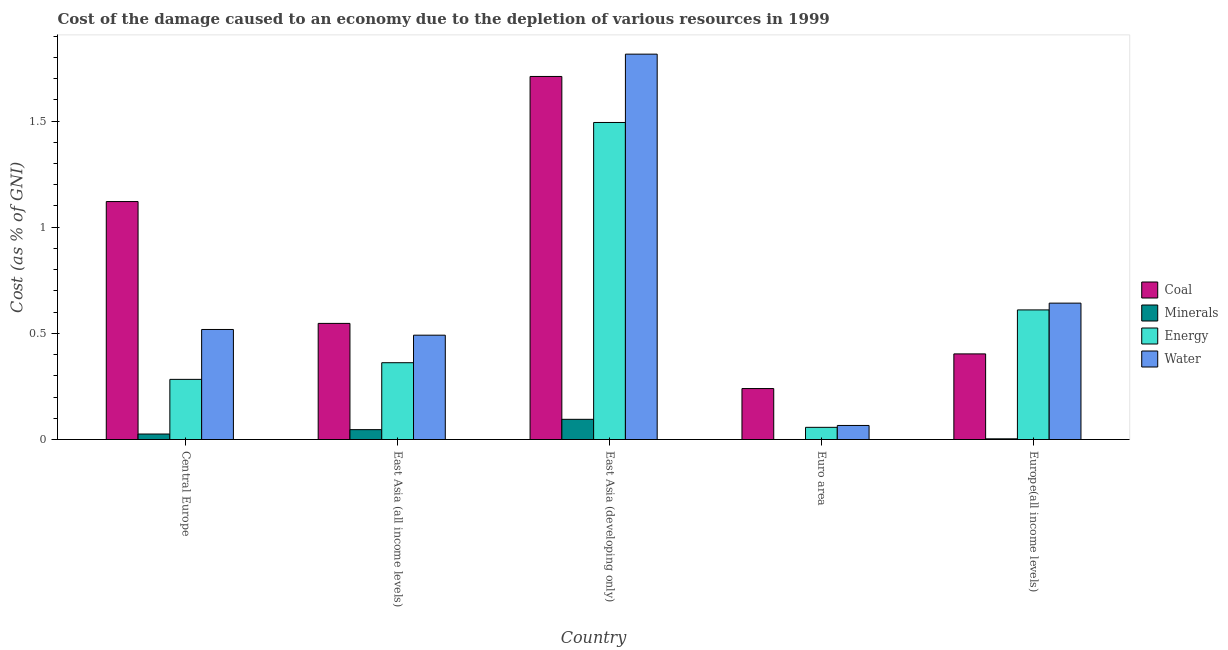What is the label of the 5th group of bars from the left?
Keep it short and to the point. Europe(all income levels). In how many cases, is the number of bars for a given country not equal to the number of legend labels?
Keep it short and to the point. 0. What is the cost of damage due to depletion of water in East Asia (all income levels)?
Offer a terse response. 0.49. Across all countries, what is the maximum cost of damage due to depletion of minerals?
Offer a terse response. 0.1. Across all countries, what is the minimum cost of damage due to depletion of coal?
Provide a short and direct response. 0.24. In which country was the cost of damage due to depletion of coal maximum?
Offer a very short reply. East Asia (developing only). What is the total cost of damage due to depletion of energy in the graph?
Your answer should be compact. 2.81. What is the difference between the cost of damage due to depletion of minerals in East Asia (developing only) and that in Euro area?
Your answer should be very brief. 0.1. What is the difference between the cost of damage due to depletion of energy in East Asia (all income levels) and the cost of damage due to depletion of water in Central Europe?
Provide a succinct answer. -0.16. What is the average cost of damage due to depletion of energy per country?
Give a very brief answer. 0.56. What is the difference between the cost of damage due to depletion of water and cost of damage due to depletion of coal in Euro area?
Keep it short and to the point. -0.17. In how many countries, is the cost of damage due to depletion of water greater than 1.7 %?
Provide a succinct answer. 1. What is the ratio of the cost of damage due to depletion of water in East Asia (developing only) to that in Euro area?
Make the answer very short. 27.42. Is the difference between the cost of damage due to depletion of water in Central Europe and East Asia (all income levels) greater than the difference between the cost of damage due to depletion of minerals in Central Europe and East Asia (all income levels)?
Your answer should be compact. Yes. What is the difference between the highest and the second highest cost of damage due to depletion of minerals?
Keep it short and to the point. 0.05. What is the difference between the highest and the lowest cost of damage due to depletion of water?
Provide a succinct answer. 1.75. What does the 3rd bar from the left in Central Europe represents?
Ensure brevity in your answer.  Energy. What does the 4th bar from the right in East Asia (developing only) represents?
Your response must be concise. Coal. Is it the case that in every country, the sum of the cost of damage due to depletion of coal and cost of damage due to depletion of minerals is greater than the cost of damage due to depletion of energy?
Provide a succinct answer. No. Are all the bars in the graph horizontal?
Make the answer very short. No. How many countries are there in the graph?
Provide a short and direct response. 5. Where does the legend appear in the graph?
Your answer should be compact. Center right. How are the legend labels stacked?
Your response must be concise. Vertical. What is the title of the graph?
Make the answer very short. Cost of the damage caused to an economy due to the depletion of various resources in 1999 . Does "Source data assessment" appear as one of the legend labels in the graph?
Keep it short and to the point. No. What is the label or title of the Y-axis?
Offer a terse response. Cost (as % of GNI). What is the Cost (as % of GNI) in Coal in Central Europe?
Make the answer very short. 1.12. What is the Cost (as % of GNI) of Minerals in Central Europe?
Make the answer very short. 0.03. What is the Cost (as % of GNI) in Energy in Central Europe?
Your response must be concise. 0.28. What is the Cost (as % of GNI) of Water in Central Europe?
Keep it short and to the point. 0.52. What is the Cost (as % of GNI) in Coal in East Asia (all income levels)?
Give a very brief answer. 0.55. What is the Cost (as % of GNI) of Minerals in East Asia (all income levels)?
Your answer should be very brief. 0.05. What is the Cost (as % of GNI) of Energy in East Asia (all income levels)?
Offer a very short reply. 0.36. What is the Cost (as % of GNI) in Water in East Asia (all income levels)?
Your response must be concise. 0.49. What is the Cost (as % of GNI) of Coal in East Asia (developing only)?
Provide a short and direct response. 1.71. What is the Cost (as % of GNI) of Minerals in East Asia (developing only)?
Your response must be concise. 0.1. What is the Cost (as % of GNI) of Energy in East Asia (developing only)?
Provide a short and direct response. 1.49. What is the Cost (as % of GNI) in Water in East Asia (developing only)?
Offer a terse response. 1.82. What is the Cost (as % of GNI) in Coal in Euro area?
Give a very brief answer. 0.24. What is the Cost (as % of GNI) in Minerals in Euro area?
Offer a very short reply. 0. What is the Cost (as % of GNI) in Energy in Euro area?
Your response must be concise. 0.06. What is the Cost (as % of GNI) of Water in Euro area?
Your answer should be very brief. 0.07. What is the Cost (as % of GNI) of Coal in Europe(all income levels)?
Offer a very short reply. 0.4. What is the Cost (as % of GNI) in Minerals in Europe(all income levels)?
Offer a very short reply. 0. What is the Cost (as % of GNI) of Energy in Europe(all income levels)?
Ensure brevity in your answer.  0.61. What is the Cost (as % of GNI) of Water in Europe(all income levels)?
Your answer should be very brief. 0.64. Across all countries, what is the maximum Cost (as % of GNI) of Coal?
Keep it short and to the point. 1.71. Across all countries, what is the maximum Cost (as % of GNI) in Minerals?
Your response must be concise. 0.1. Across all countries, what is the maximum Cost (as % of GNI) of Energy?
Your response must be concise. 1.49. Across all countries, what is the maximum Cost (as % of GNI) in Water?
Offer a terse response. 1.82. Across all countries, what is the minimum Cost (as % of GNI) of Coal?
Provide a succinct answer. 0.24. Across all countries, what is the minimum Cost (as % of GNI) of Minerals?
Provide a short and direct response. 0. Across all countries, what is the minimum Cost (as % of GNI) in Energy?
Ensure brevity in your answer.  0.06. Across all countries, what is the minimum Cost (as % of GNI) of Water?
Provide a succinct answer. 0.07. What is the total Cost (as % of GNI) of Coal in the graph?
Provide a succinct answer. 4.02. What is the total Cost (as % of GNI) of Minerals in the graph?
Your answer should be very brief. 0.17. What is the total Cost (as % of GNI) in Energy in the graph?
Make the answer very short. 2.81. What is the total Cost (as % of GNI) in Water in the graph?
Your response must be concise. 3.53. What is the difference between the Cost (as % of GNI) in Coal in Central Europe and that in East Asia (all income levels)?
Ensure brevity in your answer.  0.57. What is the difference between the Cost (as % of GNI) in Minerals in Central Europe and that in East Asia (all income levels)?
Offer a very short reply. -0.02. What is the difference between the Cost (as % of GNI) of Energy in Central Europe and that in East Asia (all income levels)?
Your answer should be very brief. -0.08. What is the difference between the Cost (as % of GNI) of Water in Central Europe and that in East Asia (all income levels)?
Offer a very short reply. 0.03. What is the difference between the Cost (as % of GNI) in Coal in Central Europe and that in East Asia (developing only)?
Make the answer very short. -0.59. What is the difference between the Cost (as % of GNI) in Minerals in Central Europe and that in East Asia (developing only)?
Your response must be concise. -0.07. What is the difference between the Cost (as % of GNI) in Energy in Central Europe and that in East Asia (developing only)?
Your answer should be very brief. -1.21. What is the difference between the Cost (as % of GNI) of Water in Central Europe and that in East Asia (developing only)?
Your response must be concise. -1.3. What is the difference between the Cost (as % of GNI) in Coal in Central Europe and that in Euro area?
Offer a very short reply. 0.88. What is the difference between the Cost (as % of GNI) in Minerals in Central Europe and that in Euro area?
Provide a succinct answer. 0.03. What is the difference between the Cost (as % of GNI) in Energy in Central Europe and that in Euro area?
Give a very brief answer. 0.23. What is the difference between the Cost (as % of GNI) in Water in Central Europe and that in Euro area?
Your answer should be very brief. 0.45. What is the difference between the Cost (as % of GNI) of Coal in Central Europe and that in Europe(all income levels)?
Ensure brevity in your answer.  0.72. What is the difference between the Cost (as % of GNI) in Minerals in Central Europe and that in Europe(all income levels)?
Your answer should be very brief. 0.02. What is the difference between the Cost (as % of GNI) of Energy in Central Europe and that in Europe(all income levels)?
Provide a short and direct response. -0.33. What is the difference between the Cost (as % of GNI) in Water in Central Europe and that in Europe(all income levels)?
Offer a terse response. -0.12. What is the difference between the Cost (as % of GNI) in Coal in East Asia (all income levels) and that in East Asia (developing only)?
Offer a terse response. -1.16. What is the difference between the Cost (as % of GNI) in Minerals in East Asia (all income levels) and that in East Asia (developing only)?
Keep it short and to the point. -0.05. What is the difference between the Cost (as % of GNI) in Energy in East Asia (all income levels) and that in East Asia (developing only)?
Offer a very short reply. -1.13. What is the difference between the Cost (as % of GNI) of Water in East Asia (all income levels) and that in East Asia (developing only)?
Provide a succinct answer. -1.32. What is the difference between the Cost (as % of GNI) of Coal in East Asia (all income levels) and that in Euro area?
Keep it short and to the point. 0.31. What is the difference between the Cost (as % of GNI) in Minerals in East Asia (all income levels) and that in Euro area?
Provide a succinct answer. 0.05. What is the difference between the Cost (as % of GNI) in Energy in East Asia (all income levels) and that in Euro area?
Give a very brief answer. 0.3. What is the difference between the Cost (as % of GNI) of Water in East Asia (all income levels) and that in Euro area?
Provide a short and direct response. 0.43. What is the difference between the Cost (as % of GNI) in Coal in East Asia (all income levels) and that in Europe(all income levels)?
Your answer should be very brief. 0.14. What is the difference between the Cost (as % of GNI) in Minerals in East Asia (all income levels) and that in Europe(all income levels)?
Offer a very short reply. 0.04. What is the difference between the Cost (as % of GNI) of Energy in East Asia (all income levels) and that in Europe(all income levels)?
Your response must be concise. -0.25. What is the difference between the Cost (as % of GNI) in Water in East Asia (all income levels) and that in Europe(all income levels)?
Ensure brevity in your answer.  -0.15. What is the difference between the Cost (as % of GNI) of Coal in East Asia (developing only) and that in Euro area?
Offer a terse response. 1.47. What is the difference between the Cost (as % of GNI) in Minerals in East Asia (developing only) and that in Euro area?
Your answer should be compact. 0.1. What is the difference between the Cost (as % of GNI) in Energy in East Asia (developing only) and that in Euro area?
Offer a terse response. 1.44. What is the difference between the Cost (as % of GNI) of Water in East Asia (developing only) and that in Euro area?
Ensure brevity in your answer.  1.75. What is the difference between the Cost (as % of GNI) in Coal in East Asia (developing only) and that in Europe(all income levels)?
Your answer should be very brief. 1.31. What is the difference between the Cost (as % of GNI) in Minerals in East Asia (developing only) and that in Europe(all income levels)?
Make the answer very short. 0.09. What is the difference between the Cost (as % of GNI) of Energy in East Asia (developing only) and that in Europe(all income levels)?
Offer a very short reply. 0.88. What is the difference between the Cost (as % of GNI) of Water in East Asia (developing only) and that in Europe(all income levels)?
Ensure brevity in your answer.  1.17. What is the difference between the Cost (as % of GNI) of Coal in Euro area and that in Europe(all income levels)?
Make the answer very short. -0.16. What is the difference between the Cost (as % of GNI) in Minerals in Euro area and that in Europe(all income levels)?
Your response must be concise. -0. What is the difference between the Cost (as % of GNI) in Energy in Euro area and that in Europe(all income levels)?
Provide a succinct answer. -0.55. What is the difference between the Cost (as % of GNI) in Water in Euro area and that in Europe(all income levels)?
Give a very brief answer. -0.58. What is the difference between the Cost (as % of GNI) in Coal in Central Europe and the Cost (as % of GNI) in Minerals in East Asia (all income levels)?
Offer a very short reply. 1.07. What is the difference between the Cost (as % of GNI) of Coal in Central Europe and the Cost (as % of GNI) of Energy in East Asia (all income levels)?
Your answer should be compact. 0.76. What is the difference between the Cost (as % of GNI) in Coal in Central Europe and the Cost (as % of GNI) in Water in East Asia (all income levels)?
Keep it short and to the point. 0.63. What is the difference between the Cost (as % of GNI) in Minerals in Central Europe and the Cost (as % of GNI) in Energy in East Asia (all income levels)?
Provide a succinct answer. -0.34. What is the difference between the Cost (as % of GNI) in Minerals in Central Europe and the Cost (as % of GNI) in Water in East Asia (all income levels)?
Make the answer very short. -0.47. What is the difference between the Cost (as % of GNI) in Energy in Central Europe and the Cost (as % of GNI) in Water in East Asia (all income levels)?
Offer a terse response. -0.21. What is the difference between the Cost (as % of GNI) of Coal in Central Europe and the Cost (as % of GNI) of Minerals in East Asia (developing only)?
Make the answer very short. 1.03. What is the difference between the Cost (as % of GNI) of Coal in Central Europe and the Cost (as % of GNI) of Energy in East Asia (developing only)?
Offer a terse response. -0.37. What is the difference between the Cost (as % of GNI) in Coal in Central Europe and the Cost (as % of GNI) in Water in East Asia (developing only)?
Ensure brevity in your answer.  -0.69. What is the difference between the Cost (as % of GNI) in Minerals in Central Europe and the Cost (as % of GNI) in Energy in East Asia (developing only)?
Give a very brief answer. -1.47. What is the difference between the Cost (as % of GNI) in Minerals in Central Europe and the Cost (as % of GNI) in Water in East Asia (developing only)?
Provide a succinct answer. -1.79. What is the difference between the Cost (as % of GNI) of Energy in Central Europe and the Cost (as % of GNI) of Water in East Asia (developing only)?
Offer a very short reply. -1.53. What is the difference between the Cost (as % of GNI) in Coal in Central Europe and the Cost (as % of GNI) in Minerals in Euro area?
Provide a succinct answer. 1.12. What is the difference between the Cost (as % of GNI) of Coal in Central Europe and the Cost (as % of GNI) of Energy in Euro area?
Give a very brief answer. 1.06. What is the difference between the Cost (as % of GNI) of Coal in Central Europe and the Cost (as % of GNI) of Water in Euro area?
Keep it short and to the point. 1.05. What is the difference between the Cost (as % of GNI) in Minerals in Central Europe and the Cost (as % of GNI) in Energy in Euro area?
Make the answer very short. -0.03. What is the difference between the Cost (as % of GNI) of Minerals in Central Europe and the Cost (as % of GNI) of Water in Euro area?
Keep it short and to the point. -0.04. What is the difference between the Cost (as % of GNI) of Energy in Central Europe and the Cost (as % of GNI) of Water in Euro area?
Your response must be concise. 0.22. What is the difference between the Cost (as % of GNI) of Coal in Central Europe and the Cost (as % of GNI) of Minerals in Europe(all income levels)?
Your answer should be very brief. 1.12. What is the difference between the Cost (as % of GNI) in Coal in Central Europe and the Cost (as % of GNI) in Energy in Europe(all income levels)?
Your answer should be compact. 0.51. What is the difference between the Cost (as % of GNI) in Coal in Central Europe and the Cost (as % of GNI) in Water in Europe(all income levels)?
Offer a very short reply. 0.48. What is the difference between the Cost (as % of GNI) in Minerals in Central Europe and the Cost (as % of GNI) in Energy in Europe(all income levels)?
Your answer should be very brief. -0.58. What is the difference between the Cost (as % of GNI) of Minerals in Central Europe and the Cost (as % of GNI) of Water in Europe(all income levels)?
Make the answer very short. -0.62. What is the difference between the Cost (as % of GNI) of Energy in Central Europe and the Cost (as % of GNI) of Water in Europe(all income levels)?
Give a very brief answer. -0.36. What is the difference between the Cost (as % of GNI) of Coal in East Asia (all income levels) and the Cost (as % of GNI) of Minerals in East Asia (developing only)?
Your response must be concise. 0.45. What is the difference between the Cost (as % of GNI) in Coal in East Asia (all income levels) and the Cost (as % of GNI) in Energy in East Asia (developing only)?
Keep it short and to the point. -0.95. What is the difference between the Cost (as % of GNI) in Coal in East Asia (all income levels) and the Cost (as % of GNI) in Water in East Asia (developing only)?
Offer a terse response. -1.27. What is the difference between the Cost (as % of GNI) in Minerals in East Asia (all income levels) and the Cost (as % of GNI) in Energy in East Asia (developing only)?
Make the answer very short. -1.45. What is the difference between the Cost (as % of GNI) in Minerals in East Asia (all income levels) and the Cost (as % of GNI) in Water in East Asia (developing only)?
Your answer should be compact. -1.77. What is the difference between the Cost (as % of GNI) in Energy in East Asia (all income levels) and the Cost (as % of GNI) in Water in East Asia (developing only)?
Your response must be concise. -1.45. What is the difference between the Cost (as % of GNI) in Coal in East Asia (all income levels) and the Cost (as % of GNI) in Minerals in Euro area?
Offer a very short reply. 0.55. What is the difference between the Cost (as % of GNI) in Coal in East Asia (all income levels) and the Cost (as % of GNI) in Energy in Euro area?
Your response must be concise. 0.49. What is the difference between the Cost (as % of GNI) in Coal in East Asia (all income levels) and the Cost (as % of GNI) in Water in Euro area?
Your response must be concise. 0.48. What is the difference between the Cost (as % of GNI) of Minerals in East Asia (all income levels) and the Cost (as % of GNI) of Energy in Euro area?
Your answer should be compact. -0.01. What is the difference between the Cost (as % of GNI) of Minerals in East Asia (all income levels) and the Cost (as % of GNI) of Water in Euro area?
Provide a succinct answer. -0.02. What is the difference between the Cost (as % of GNI) in Energy in East Asia (all income levels) and the Cost (as % of GNI) in Water in Euro area?
Keep it short and to the point. 0.3. What is the difference between the Cost (as % of GNI) in Coal in East Asia (all income levels) and the Cost (as % of GNI) in Minerals in Europe(all income levels)?
Keep it short and to the point. 0.54. What is the difference between the Cost (as % of GNI) of Coal in East Asia (all income levels) and the Cost (as % of GNI) of Energy in Europe(all income levels)?
Ensure brevity in your answer.  -0.06. What is the difference between the Cost (as % of GNI) in Coal in East Asia (all income levels) and the Cost (as % of GNI) in Water in Europe(all income levels)?
Your answer should be very brief. -0.1. What is the difference between the Cost (as % of GNI) in Minerals in East Asia (all income levels) and the Cost (as % of GNI) in Energy in Europe(all income levels)?
Keep it short and to the point. -0.56. What is the difference between the Cost (as % of GNI) in Minerals in East Asia (all income levels) and the Cost (as % of GNI) in Water in Europe(all income levels)?
Make the answer very short. -0.6. What is the difference between the Cost (as % of GNI) in Energy in East Asia (all income levels) and the Cost (as % of GNI) in Water in Europe(all income levels)?
Your response must be concise. -0.28. What is the difference between the Cost (as % of GNI) in Coal in East Asia (developing only) and the Cost (as % of GNI) in Minerals in Euro area?
Your answer should be compact. 1.71. What is the difference between the Cost (as % of GNI) of Coal in East Asia (developing only) and the Cost (as % of GNI) of Energy in Euro area?
Provide a succinct answer. 1.65. What is the difference between the Cost (as % of GNI) of Coal in East Asia (developing only) and the Cost (as % of GNI) of Water in Euro area?
Keep it short and to the point. 1.64. What is the difference between the Cost (as % of GNI) in Minerals in East Asia (developing only) and the Cost (as % of GNI) in Energy in Euro area?
Make the answer very short. 0.04. What is the difference between the Cost (as % of GNI) in Minerals in East Asia (developing only) and the Cost (as % of GNI) in Water in Euro area?
Provide a succinct answer. 0.03. What is the difference between the Cost (as % of GNI) in Energy in East Asia (developing only) and the Cost (as % of GNI) in Water in Euro area?
Your answer should be very brief. 1.43. What is the difference between the Cost (as % of GNI) in Coal in East Asia (developing only) and the Cost (as % of GNI) in Minerals in Europe(all income levels)?
Give a very brief answer. 1.71. What is the difference between the Cost (as % of GNI) in Coal in East Asia (developing only) and the Cost (as % of GNI) in Energy in Europe(all income levels)?
Give a very brief answer. 1.1. What is the difference between the Cost (as % of GNI) in Coal in East Asia (developing only) and the Cost (as % of GNI) in Water in Europe(all income levels)?
Offer a terse response. 1.07. What is the difference between the Cost (as % of GNI) of Minerals in East Asia (developing only) and the Cost (as % of GNI) of Energy in Europe(all income levels)?
Provide a short and direct response. -0.52. What is the difference between the Cost (as % of GNI) in Minerals in East Asia (developing only) and the Cost (as % of GNI) in Water in Europe(all income levels)?
Your response must be concise. -0.55. What is the difference between the Cost (as % of GNI) in Energy in East Asia (developing only) and the Cost (as % of GNI) in Water in Europe(all income levels)?
Provide a succinct answer. 0.85. What is the difference between the Cost (as % of GNI) of Coal in Euro area and the Cost (as % of GNI) of Minerals in Europe(all income levels)?
Keep it short and to the point. 0.24. What is the difference between the Cost (as % of GNI) of Coal in Euro area and the Cost (as % of GNI) of Energy in Europe(all income levels)?
Offer a terse response. -0.37. What is the difference between the Cost (as % of GNI) of Coal in Euro area and the Cost (as % of GNI) of Water in Europe(all income levels)?
Your response must be concise. -0.4. What is the difference between the Cost (as % of GNI) in Minerals in Euro area and the Cost (as % of GNI) in Energy in Europe(all income levels)?
Provide a short and direct response. -0.61. What is the difference between the Cost (as % of GNI) in Minerals in Euro area and the Cost (as % of GNI) in Water in Europe(all income levels)?
Give a very brief answer. -0.64. What is the difference between the Cost (as % of GNI) in Energy in Euro area and the Cost (as % of GNI) in Water in Europe(all income levels)?
Keep it short and to the point. -0.58. What is the average Cost (as % of GNI) in Coal per country?
Ensure brevity in your answer.  0.8. What is the average Cost (as % of GNI) of Minerals per country?
Provide a short and direct response. 0.03. What is the average Cost (as % of GNI) of Energy per country?
Offer a very short reply. 0.56. What is the average Cost (as % of GNI) of Water per country?
Ensure brevity in your answer.  0.71. What is the difference between the Cost (as % of GNI) in Coal and Cost (as % of GNI) in Minerals in Central Europe?
Provide a short and direct response. 1.09. What is the difference between the Cost (as % of GNI) in Coal and Cost (as % of GNI) in Energy in Central Europe?
Your response must be concise. 0.84. What is the difference between the Cost (as % of GNI) in Coal and Cost (as % of GNI) in Water in Central Europe?
Give a very brief answer. 0.6. What is the difference between the Cost (as % of GNI) of Minerals and Cost (as % of GNI) of Energy in Central Europe?
Your answer should be very brief. -0.26. What is the difference between the Cost (as % of GNI) in Minerals and Cost (as % of GNI) in Water in Central Europe?
Offer a terse response. -0.49. What is the difference between the Cost (as % of GNI) in Energy and Cost (as % of GNI) in Water in Central Europe?
Your answer should be very brief. -0.23. What is the difference between the Cost (as % of GNI) in Coal and Cost (as % of GNI) in Minerals in East Asia (all income levels)?
Your answer should be compact. 0.5. What is the difference between the Cost (as % of GNI) in Coal and Cost (as % of GNI) in Energy in East Asia (all income levels)?
Your response must be concise. 0.19. What is the difference between the Cost (as % of GNI) in Coal and Cost (as % of GNI) in Water in East Asia (all income levels)?
Give a very brief answer. 0.06. What is the difference between the Cost (as % of GNI) in Minerals and Cost (as % of GNI) in Energy in East Asia (all income levels)?
Give a very brief answer. -0.32. What is the difference between the Cost (as % of GNI) of Minerals and Cost (as % of GNI) of Water in East Asia (all income levels)?
Offer a terse response. -0.44. What is the difference between the Cost (as % of GNI) in Energy and Cost (as % of GNI) in Water in East Asia (all income levels)?
Offer a very short reply. -0.13. What is the difference between the Cost (as % of GNI) of Coal and Cost (as % of GNI) of Minerals in East Asia (developing only)?
Your response must be concise. 1.61. What is the difference between the Cost (as % of GNI) in Coal and Cost (as % of GNI) in Energy in East Asia (developing only)?
Offer a very short reply. 0.22. What is the difference between the Cost (as % of GNI) in Coal and Cost (as % of GNI) in Water in East Asia (developing only)?
Offer a very short reply. -0.11. What is the difference between the Cost (as % of GNI) of Minerals and Cost (as % of GNI) of Energy in East Asia (developing only)?
Your answer should be very brief. -1.4. What is the difference between the Cost (as % of GNI) in Minerals and Cost (as % of GNI) in Water in East Asia (developing only)?
Provide a short and direct response. -1.72. What is the difference between the Cost (as % of GNI) in Energy and Cost (as % of GNI) in Water in East Asia (developing only)?
Offer a very short reply. -0.32. What is the difference between the Cost (as % of GNI) of Coal and Cost (as % of GNI) of Minerals in Euro area?
Provide a succinct answer. 0.24. What is the difference between the Cost (as % of GNI) of Coal and Cost (as % of GNI) of Energy in Euro area?
Offer a terse response. 0.18. What is the difference between the Cost (as % of GNI) of Coal and Cost (as % of GNI) of Water in Euro area?
Your response must be concise. 0.17. What is the difference between the Cost (as % of GNI) of Minerals and Cost (as % of GNI) of Energy in Euro area?
Make the answer very short. -0.06. What is the difference between the Cost (as % of GNI) in Minerals and Cost (as % of GNI) in Water in Euro area?
Provide a short and direct response. -0.07. What is the difference between the Cost (as % of GNI) of Energy and Cost (as % of GNI) of Water in Euro area?
Provide a succinct answer. -0.01. What is the difference between the Cost (as % of GNI) of Coal and Cost (as % of GNI) of Minerals in Europe(all income levels)?
Offer a terse response. 0.4. What is the difference between the Cost (as % of GNI) of Coal and Cost (as % of GNI) of Energy in Europe(all income levels)?
Your response must be concise. -0.21. What is the difference between the Cost (as % of GNI) of Coal and Cost (as % of GNI) of Water in Europe(all income levels)?
Offer a very short reply. -0.24. What is the difference between the Cost (as % of GNI) of Minerals and Cost (as % of GNI) of Energy in Europe(all income levels)?
Offer a very short reply. -0.61. What is the difference between the Cost (as % of GNI) of Minerals and Cost (as % of GNI) of Water in Europe(all income levels)?
Your answer should be compact. -0.64. What is the difference between the Cost (as % of GNI) in Energy and Cost (as % of GNI) in Water in Europe(all income levels)?
Offer a terse response. -0.03. What is the ratio of the Cost (as % of GNI) of Coal in Central Europe to that in East Asia (all income levels)?
Your response must be concise. 2.05. What is the ratio of the Cost (as % of GNI) of Minerals in Central Europe to that in East Asia (all income levels)?
Your response must be concise. 0.56. What is the ratio of the Cost (as % of GNI) of Energy in Central Europe to that in East Asia (all income levels)?
Provide a short and direct response. 0.78. What is the ratio of the Cost (as % of GNI) of Water in Central Europe to that in East Asia (all income levels)?
Give a very brief answer. 1.05. What is the ratio of the Cost (as % of GNI) of Coal in Central Europe to that in East Asia (developing only)?
Provide a succinct answer. 0.66. What is the ratio of the Cost (as % of GNI) of Minerals in Central Europe to that in East Asia (developing only)?
Keep it short and to the point. 0.27. What is the ratio of the Cost (as % of GNI) in Energy in Central Europe to that in East Asia (developing only)?
Give a very brief answer. 0.19. What is the ratio of the Cost (as % of GNI) in Water in Central Europe to that in East Asia (developing only)?
Keep it short and to the point. 0.29. What is the ratio of the Cost (as % of GNI) of Coal in Central Europe to that in Euro area?
Provide a short and direct response. 4.67. What is the ratio of the Cost (as % of GNI) of Minerals in Central Europe to that in Euro area?
Provide a short and direct response. 222.12. What is the ratio of the Cost (as % of GNI) of Energy in Central Europe to that in Euro area?
Your answer should be very brief. 4.94. What is the ratio of the Cost (as % of GNI) of Water in Central Europe to that in Euro area?
Provide a succinct answer. 7.83. What is the ratio of the Cost (as % of GNI) of Coal in Central Europe to that in Europe(all income levels)?
Provide a succinct answer. 2.78. What is the ratio of the Cost (as % of GNI) of Minerals in Central Europe to that in Europe(all income levels)?
Keep it short and to the point. 7.99. What is the ratio of the Cost (as % of GNI) in Energy in Central Europe to that in Europe(all income levels)?
Offer a very short reply. 0.46. What is the ratio of the Cost (as % of GNI) of Water in Central Europe to that in Europe(all income levels)?
Give a very brief answer. 0.81. What is the ratio of the Cost (as % of GNI) in Coal in East Asia (all income levels) to that in East Asia (developing only)?
Your response must be concise. 0.32. What is the ratio of the Cost (as % of GNI) of Minerals in East Asia (all income levels) to that in East Asia (developing only)?
Keep it short and to the point. 0.49. What is the ratio of the Cost (as % of GNI) of Energy in East Asia (all income levels) to that in East Asia (developing only)?
Your response must be concise. 0.24. What is the ratio of the Cost (as % of GNI) in Water in East Asia (all income levels) to that in East Asia (developing only)?
Offer a very short reply. 0.27. What is the ratio of the Cost (as % of GNI) of Coal in East Asia (all income levels) to that in Euro area?
Provide a succinct answer. 2.28. What is the ratio of the Cost (as % of GNI) in Minerals in East Asia (all income levels) to that in Euro area?
Make the answer very short. 398.85. What is the ratio of the Cost (as % of GNI) of Energy in East Asia (all income levels) to that in Euro area?
Your answer should be very brief. 6.3. What is the ratio of the Cost (as % of GNI) of Water in East Asia (all income levels) to that in Euro area?
Provide a short and direct response. 7.42. What is the ratio of the Cost (as % of GNI) in Coal in East Asia (all income levels) to that in Europe(all income levels)?
Offer a very short reply. 1.36. What is the ratio of the Cost (as % of GNI) of Minerals in East Asia (all income levels) to that in Europe(all income levels)?
Make the answer very short. 14.35. What is the ratio of the Cost (as % of GNI) in Energy in East Asia (all income levels) to that in Europe(all income levels)?
Give a very brief answer. 0.59. What is the ratio of the Cost (as % of GNI) in Water in East Asia (all income levels) to that in Europe(all income levels)?
Offer a very short reply. 0.77. What is the ratio of the Cost (as % of GNI) of Coal in East Asia (developing only) to that in Euro area?
Your answer should be compact. 7.12. What is the ratio of the Cost (as % of GNI) in Minerals in East Asia (developing only) to that in Euro area?
Provide a succinct answer. 815.69. What is the ratio of the Cost (as % of GNI) in Energy in East Asia (developing only) to that in Euro area?
Give a very brief answer. 26.02. What is the ratio of the Cost (as % of GNI) in Water in East Asia (developing only) to that in Euro area?
Make the answer very short. 27.42. What is the ratio of the Cost (as % of GNI) in Coal in East Asia (developing only) to that in Europe(all income levels)?
Your response must be concise. 4.24. What is the ratio of the Cost (as % of GNI) in Minerals in East Asia (developing only) to that in Europe(all income levels)?
Ensure brevity in your answer.  29.35. What is the ratio of the Cost (as % of GNI) of Energy in East Asia (developing only) to that in Europe(all income levels)?
Provide a short and direct response. 2.45. What is the ratio of the Cost (as % of GNI) in Water in East Asia (developing only) to that in Europe(all income levels)?
Keep it short and to the point. 2.83. What is the ratio of the Cost (as % of GNI) of Coal in Euro area to that in Europe(all income levels)?
Give a very brief answer. 0.6. What is the ratio of the Cost (as % of GNI) in Minerals in Euro area to that in Europe(all income levels)?
Give a very brief answer. 0.04. What is the ratio of the Cost (as % of GNI) of Energy in Euro area to that in Europe(all income levels)?
Your answer should be compact. 0.09. What is the ratio of the Cost (as % of GNI) of Water in Euro area to that in Europe(all income levels)?
Offer a very short reply. 0.1. What is the difference between the highest and the second highest Cost (as % of GNI) of Coal?
Your response must be concise. 0.59. What is the difference between the highest and the second highest Cost (as % of GNI) in Minerals?
Provide a short and direct response. 0.05. What is the difference between the highest and the second highest Cost (as % of GNI) of Energy?
Provide a succinct answer. 0.88. What is the difference between the highest and the second highest Cost (as % of GNI) of Water?
Provide a succinct answer. 1.17. What is the difference between the highest and the lowest Cost (as % of GNI) in Coal?
Your response must be concise. 1.47. What is the difference between the highest and the lowest Cost (as % of GNI) of Minerals?
Provide a short and direct response. 0.1. What is the difference between the highest and the lowest Cost (as % of GNI) of Energy?
Provide a short and direct response. 1.44. What is the difference between the highest and the lowest Cost (as % of GNI) of Water?
Provide a succinct answer. 1.75. 